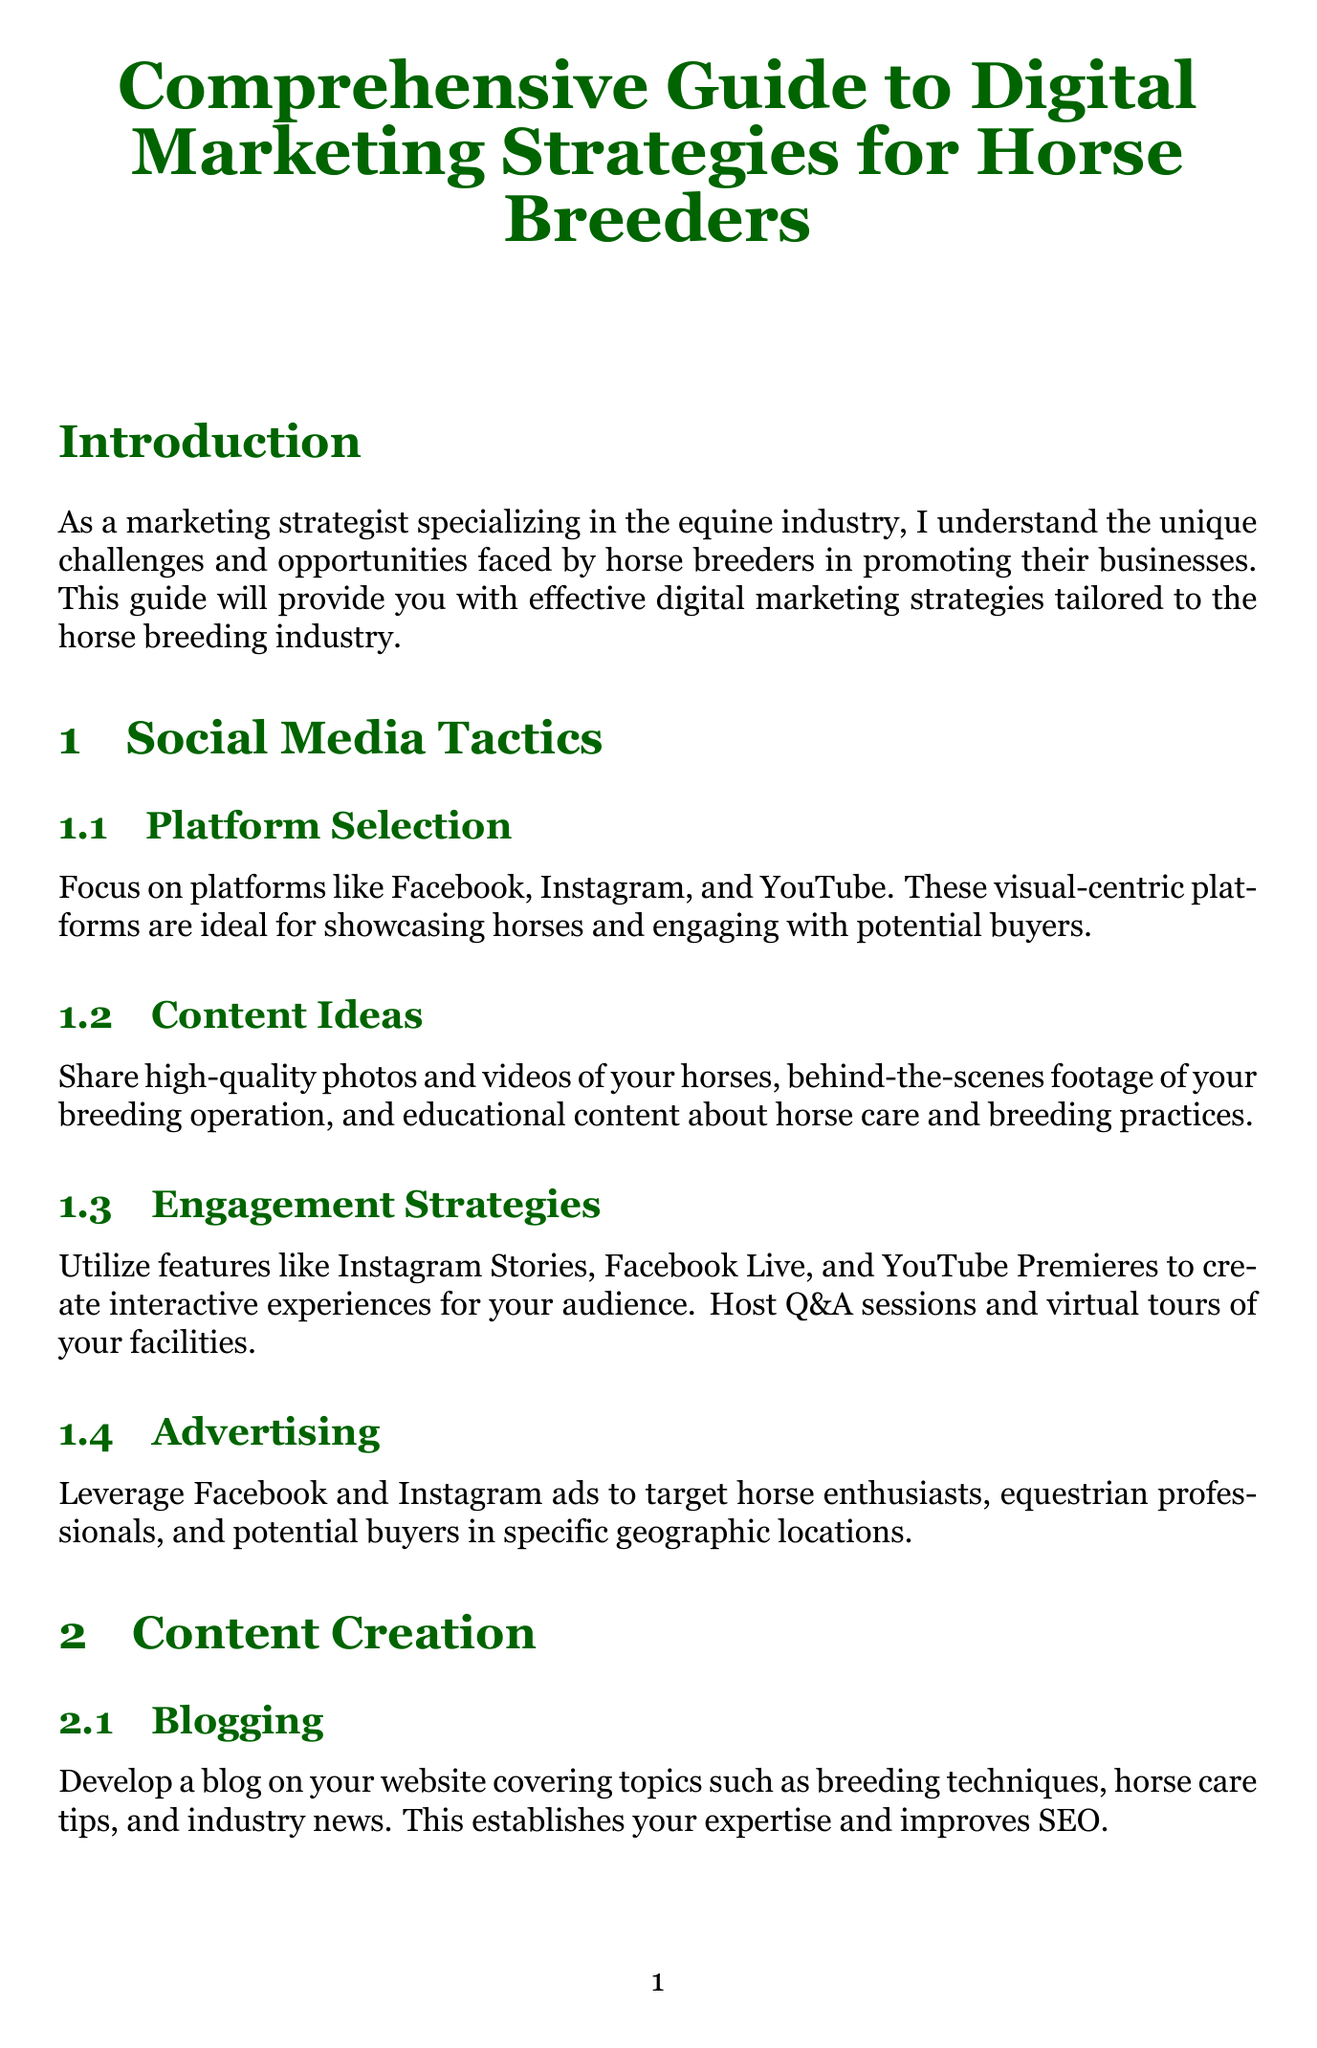what is the title of the document? The title is stated at the beginning of the document as a comprehensive guide meant for horse breeders.
Answer: Comprehensive Guide to Digital Marketing Strategies for Horse Breeders which social media platforms are recommended? The document lists the ideal platforms for horse breeders to engage with potential buyers.
Answer: Facebook, Instagram, and YouTube what is one content idea for social media? The document suggests sharing various content types to engage the audience effectively.
Answer: High-quality photos and videos of your horses what is a key aspect of SEO optimization mentioned? The section discusses several techniques for optimizing a website to improve search engine ranking.
Answer: Keyword Research what tool is recommended for email marketing? The document provides suggestions for tools to manage email campaigns effectively.
Answer: Mailchimp or Constant Contact what should be monitored for online reputation management? This involves keeping track of the feedback received about the breeding program.
Answer: Mentions of your breeding program online what online event type is suggested for horse breeders? The guide offers ideas for events breeders can host to engage with audiences.
Answer: Virtual horse auctions who can horse breeders collaborate with for influencer partnerships? The document identifies potential partners that can help increase visibility.
Answer: Equestrian influencers what is the purpose of content blogging according to the guide? The document explains the significance of maintaining a blog in relation to market positioning.
Answer: Establish expertise and improve SEO 